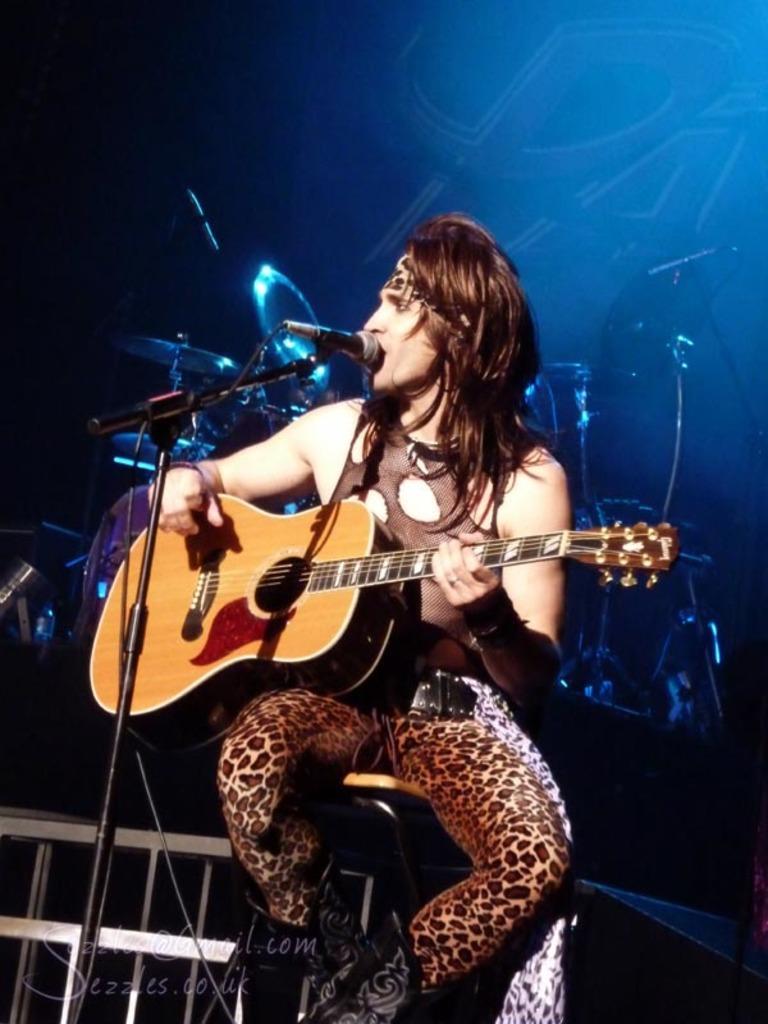In one or two sentences, can you explain what this image depicts? In this image the man is sitting and playing a guitar. 